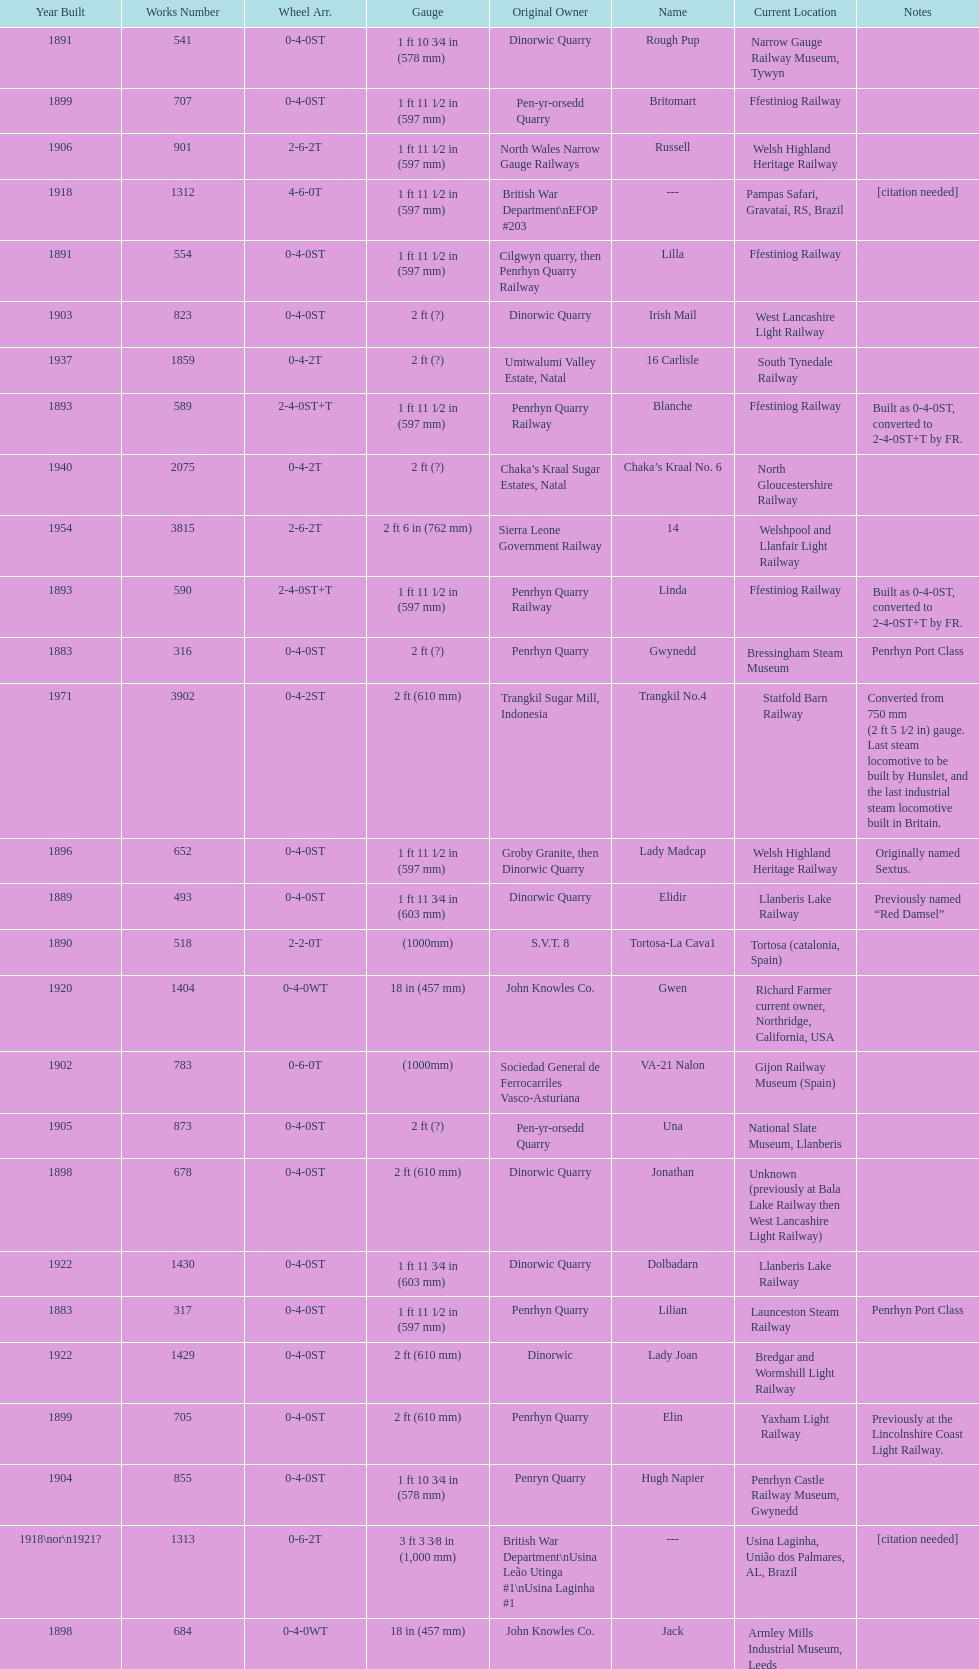What is the works number of the only item built in 1882? 283. 